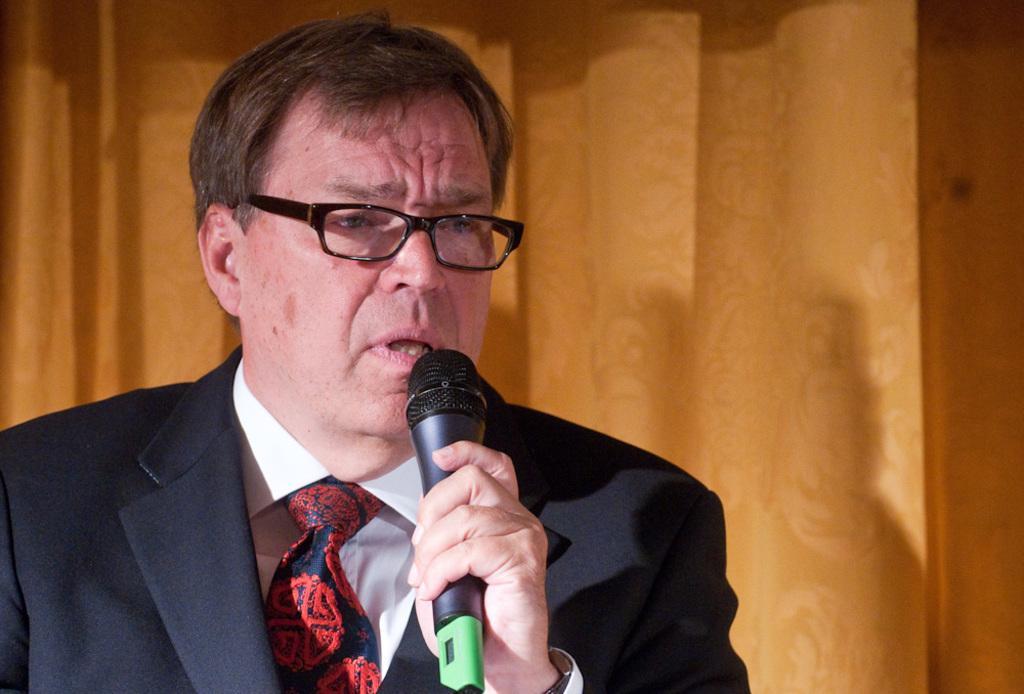Please provide a concise description of this image. I can see in this image a man is wearing a suit and spectacles is holding a microphone in his hand. 